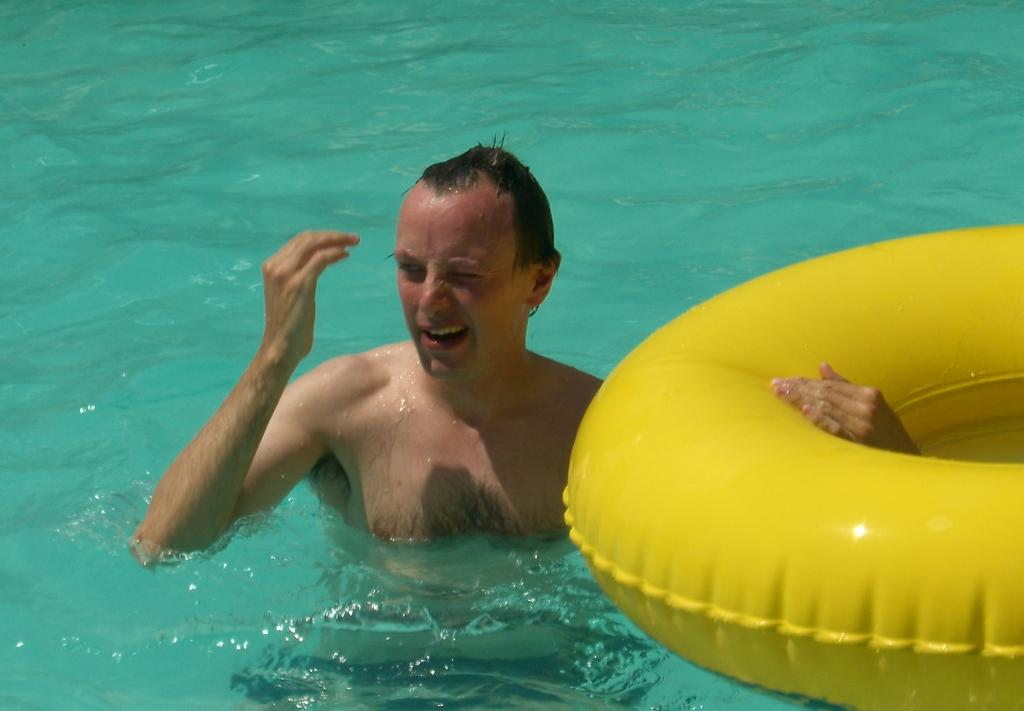What is the man in the image doing? The man is in the water. What object is on the water with the man? There is a yellow color inflatable ring on the water. Where is the inflatable ring located in the image? The inflatable ring is on the right side of the image. What can be seen in the background of the image? There is water visible in the background of the image. What type of zephyr is the man using to stay afloat in the image? There is no mention of a zephyr in the image; the man is using a yellow color inflatable ring to stay afloat. 